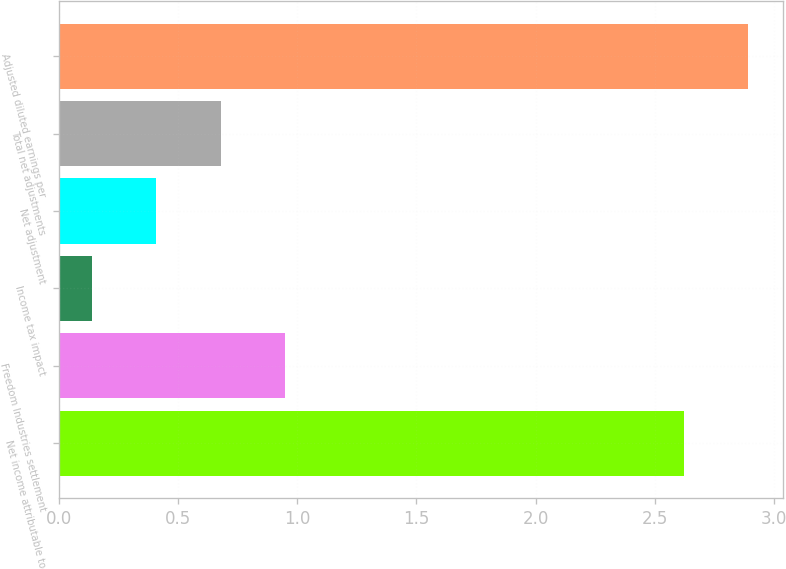Convert chart. <chart><loc_0><loc_0><loc_500><loc_500><bar_chart><fcel>Net income attributable to<fcel>Freedom Industries settlement<fcel>Income tax impact<fcel>Net adjustment<fcel>Total net adjustments<fcel>Adjusted diluted earnings per<nl><fcel>2.62<fcel>0.95<fcel>0.14<fcel>0.41<fcel>0.68<fcel>2.89<nl></chart> 